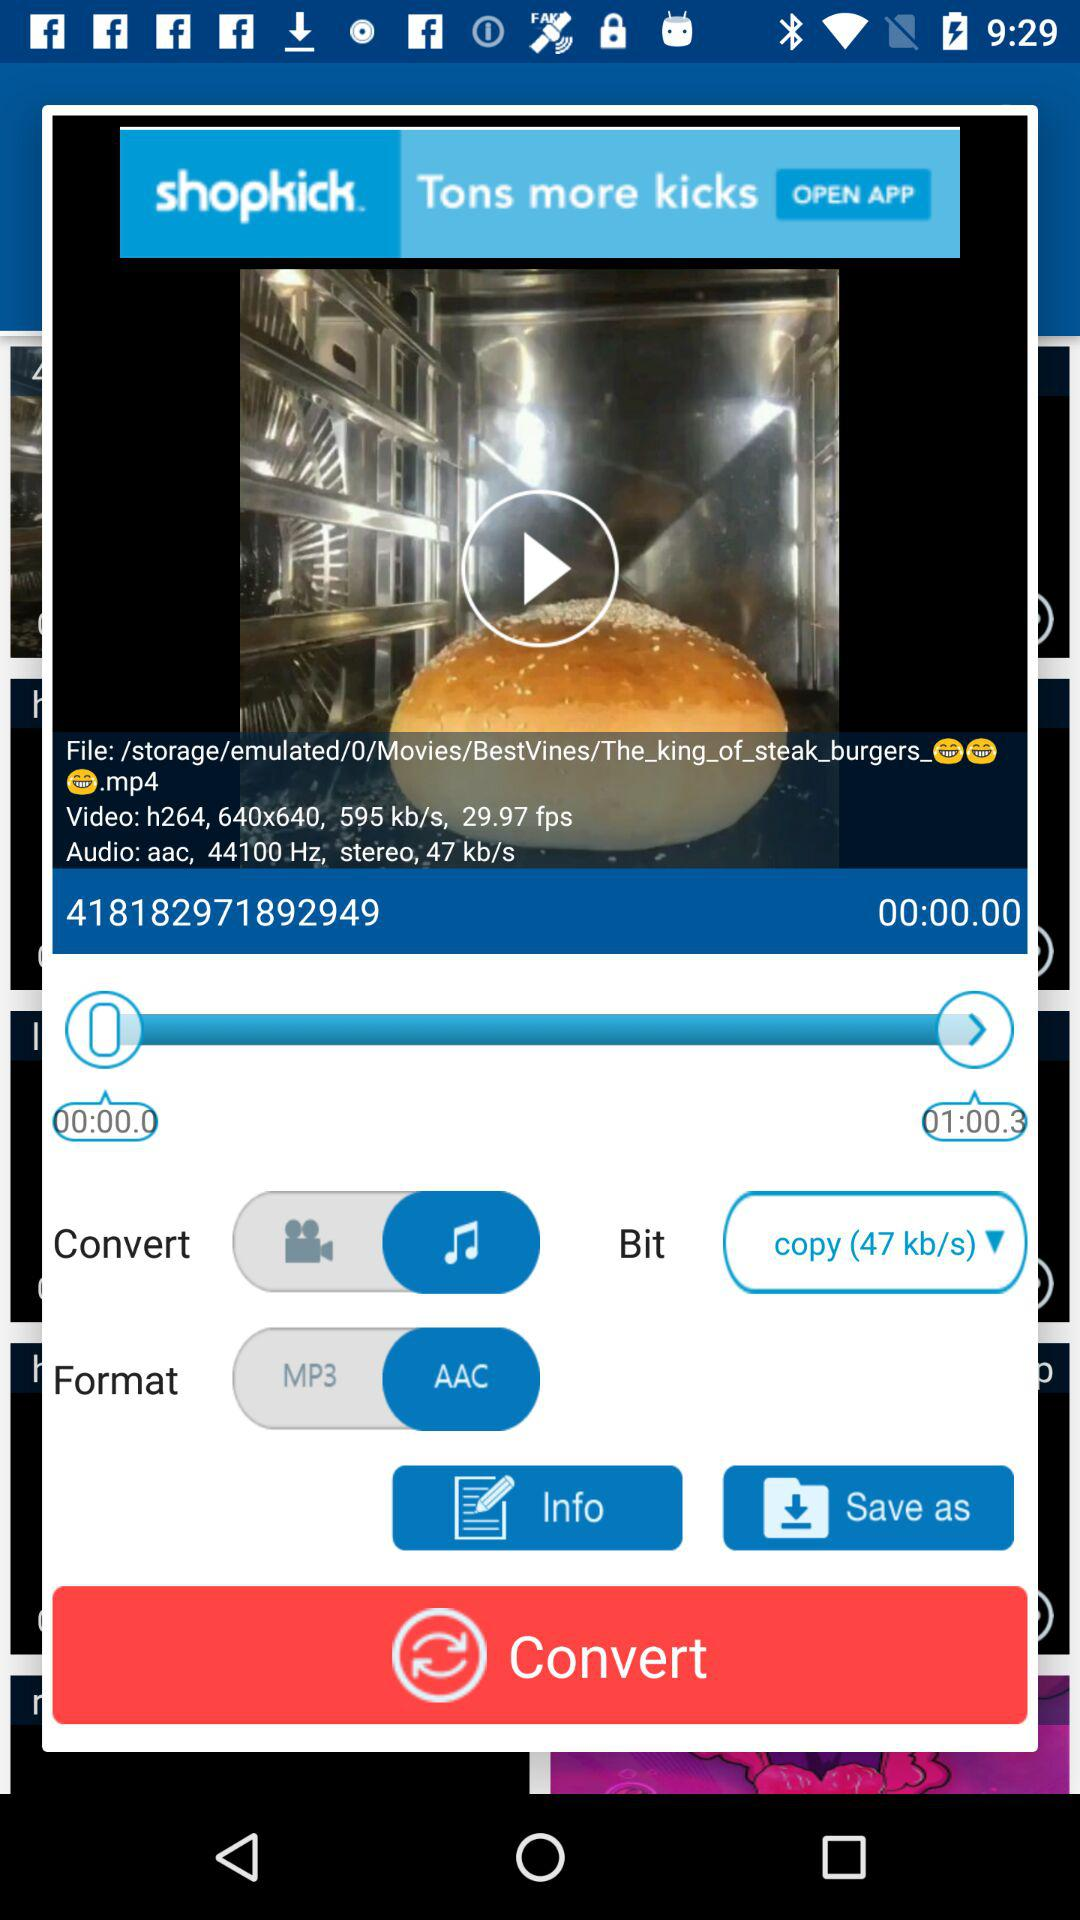How many audio formats are available?
Answer the question using a single word or phrase. 2 